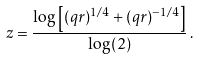<formula> <loc_0><loc_0><loc_500><loc_500>z = \frac { \log \left [ ( q r ) ^ { 1 / 4 } + ( q r ) ^ { - 1 / 4 } \right ] } { \log ( 2 ) } \, .</formula> 